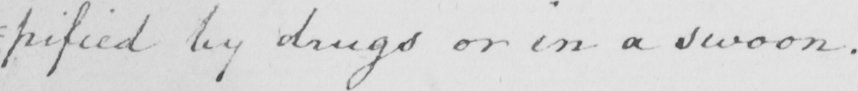What does this handwritten line say? : pified by drugs or in a swoon . 